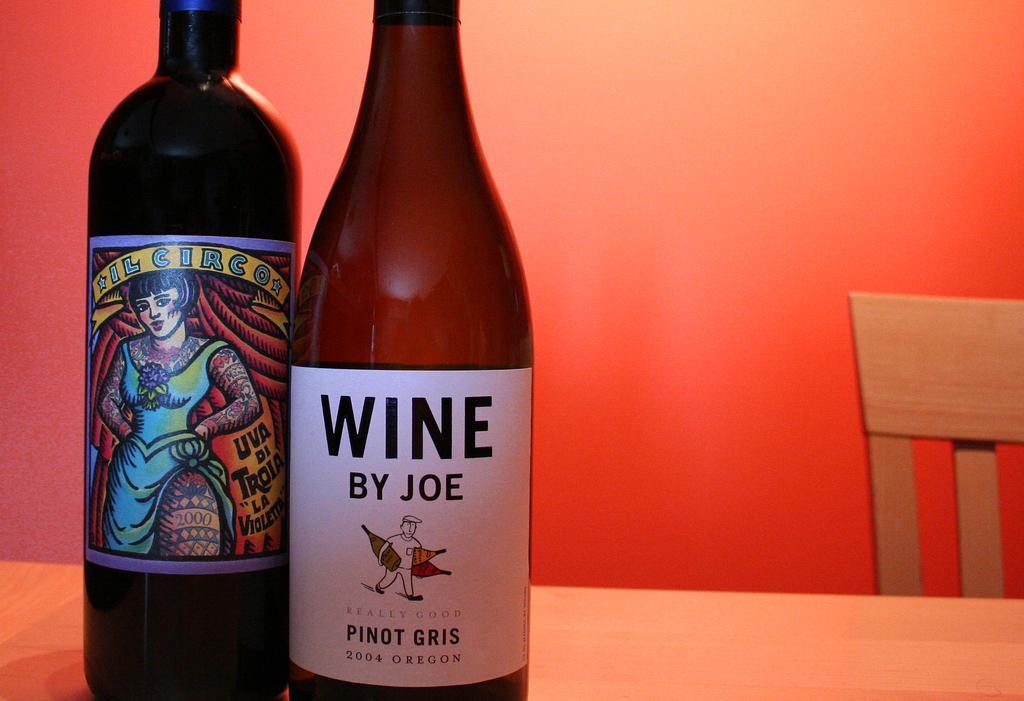<image>
Render a clear and concise summary of the photo. A bottle of Wine by Joe is next to another bottle of wine. 